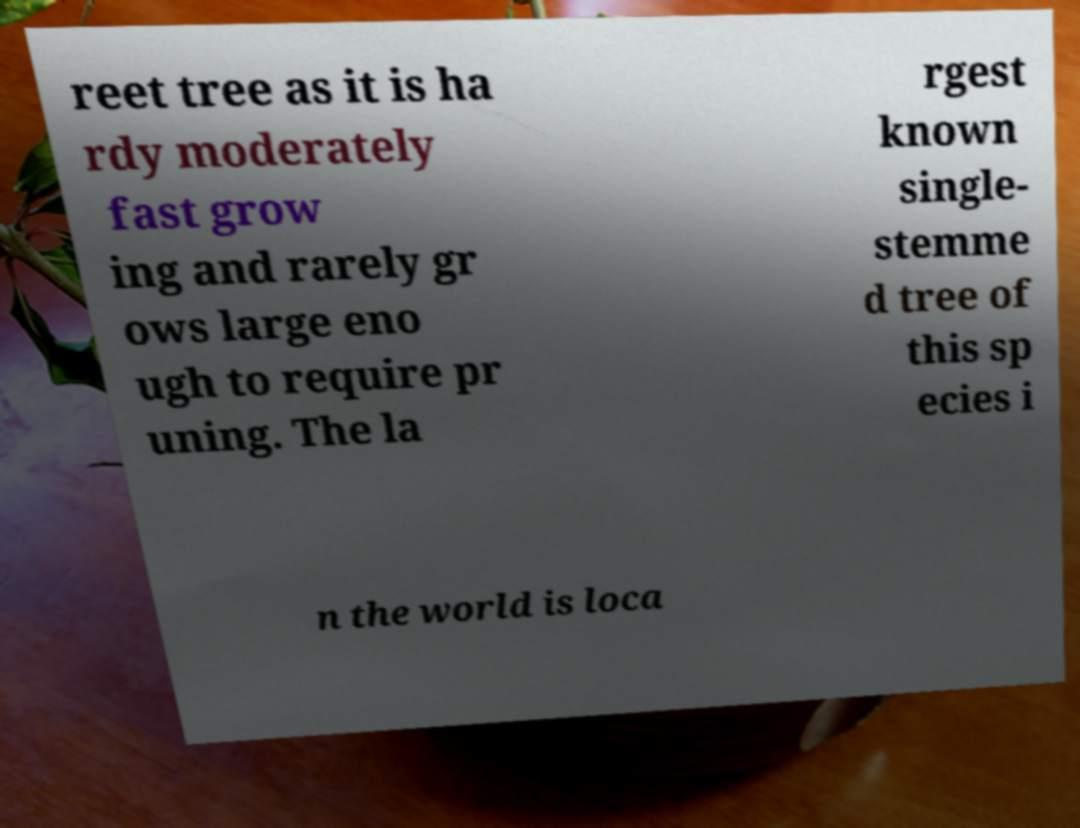Please identify and transcribe the text found in this image. reet tree as it is ha rdy moderately fast grow ing and rarely gr ows large eno ugh to require pr uning. The la rgest known single- stemme d tree of this sp ecies i n the world is loca 